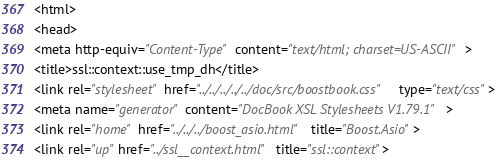Convert code to text. <code><loc_0><loc_0><loc_500><loc_500><_HTML_><html>
<head>
<meta http-equiv="Content-Type" content="text/html; charset=US-ASCII">
<title>ssl::context::use_tmp_dh</title>
<link rel="stylesheet" href="../../../../../doc/src/boostbook.css" type="text/css">
<meta name="generator" content="DocBook XSL Stylesheets V1.79.1">
<link rel="home" href="../../../boost_asio.html" title="Boost.Asio">
<link rel="up" href="../ssl__context.html" title="ssl::context"></code> 